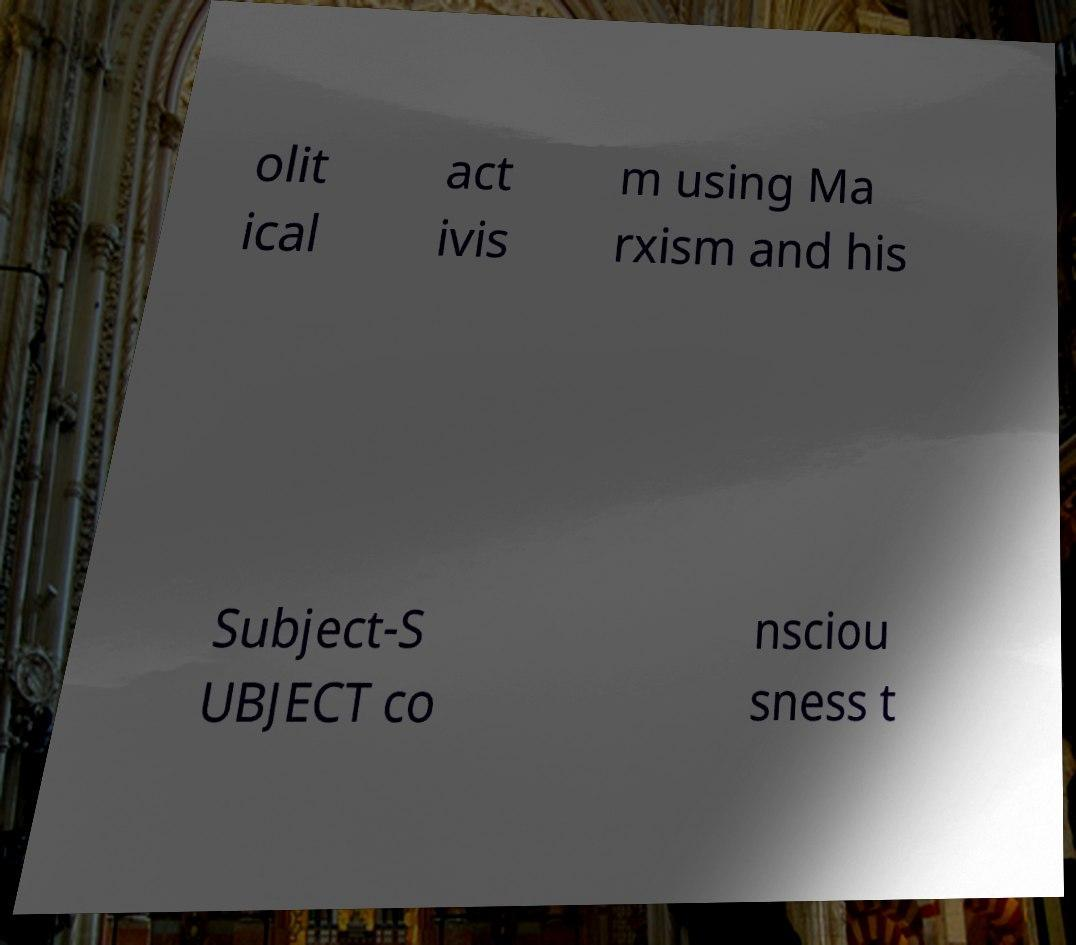Can you read and provide the text displayed in the image?This photo seems to have some interesting text. Can you extract and type it out for me? olit ical act ivis m using Ma rxism and his Subject-S UBJECT co nsciou sness t 